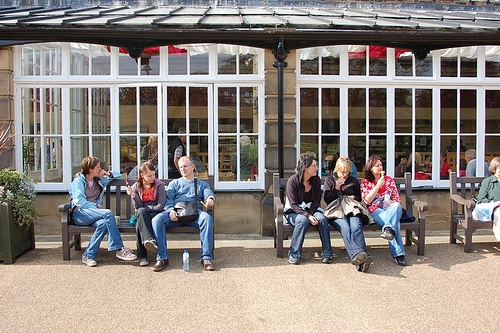Describe the objects in this image and their specific colors. I can see people in gray, lightgray, and black tones, people in gray, lightblue, blue, and lightgray tones, people in gray, black, darkgray, and navy tones, potted plant in gray, black, darkgreen, and darkgray tones, and people in gray, white, lightpink, and black tones in this image. 